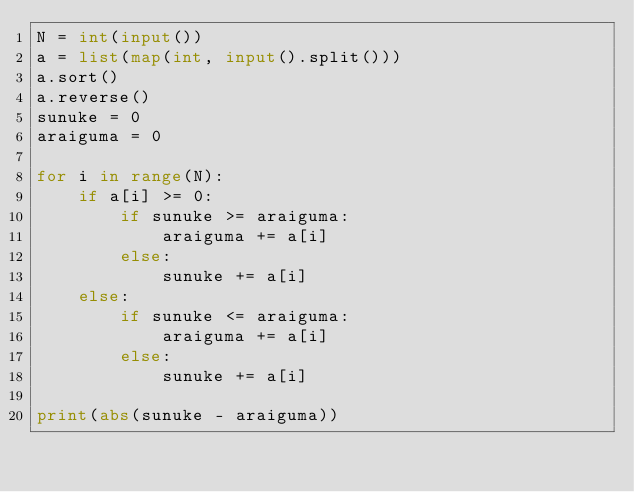Convert code to text. <code><loc_0><loc_0><loc_500><loc_500><_Python_>N = int(input())
a = list(map(int, input().split()))
a.sort()
a.reverse()
sunuke = 0
araiguma = 0

for i in range(N):
    if a[i] >= 0:
        if sunuke >= araiguma:
            araiguma += a[i]
        else:
            sunuke += a[i]
    else:
        if sunuke <= araiguma:
            araiguma += a[i]
        else:
            sunuke += a[i]

print(abs(sunuke - araiguma))</code> 